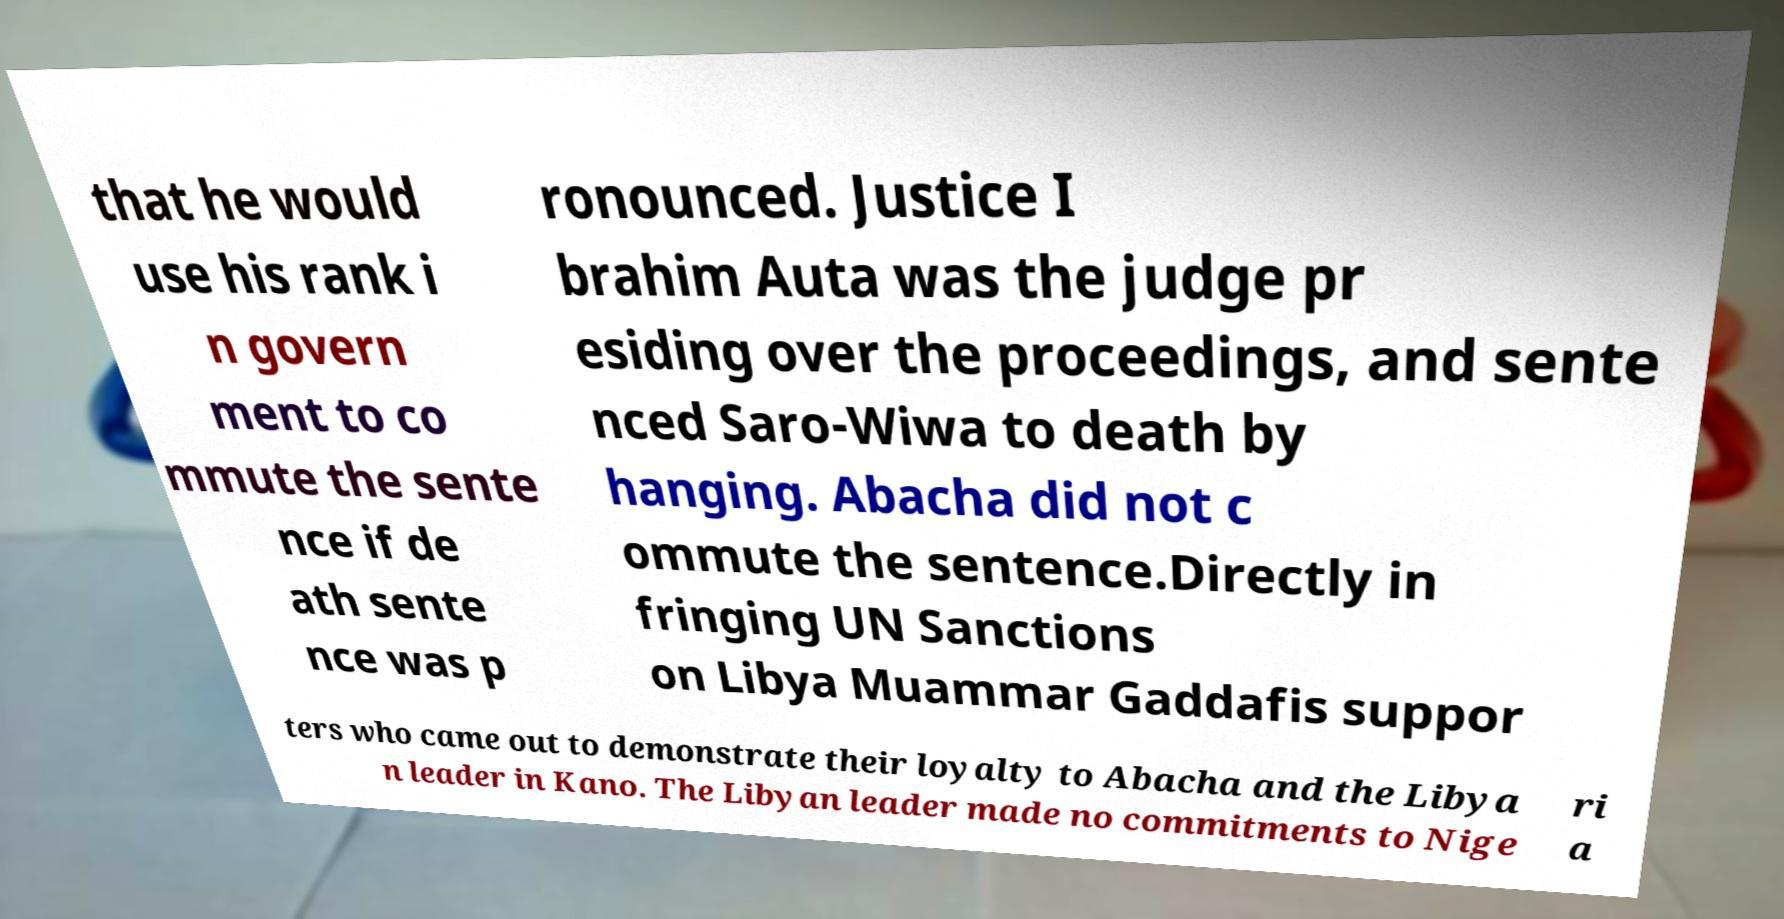Could you assist in decoding the text presented in this image and type it out clearly? that he would use his rank i n govern ment to co mmute the sente nce if de ath sente nce was p ronounced. Justice I brahim Auta was the judge pr esiding over the proceedings, and sente nced Saro-Wiwa to death by hanging. Abacha did not c ommute the sentence.Directly in fringing UN Sanctions on Libya Muammar Gaddafis suppor ters who came out to demonstrate their loyalty to Abacha and the Libya n leader in Kano. The Libyan leader made no commitments to Nige ri a 